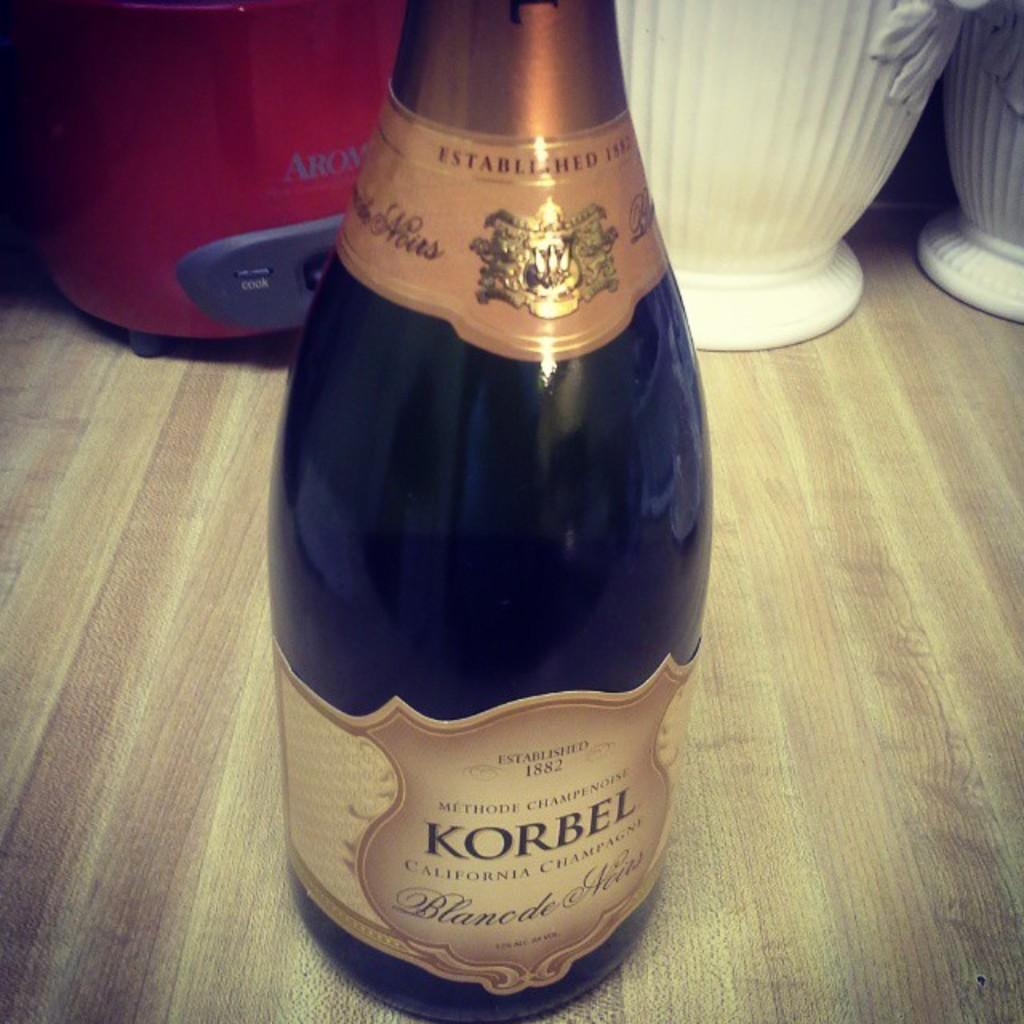Provide a one-sentence caption for the provided image. a bottle of wine called korbel placed on the counter. 